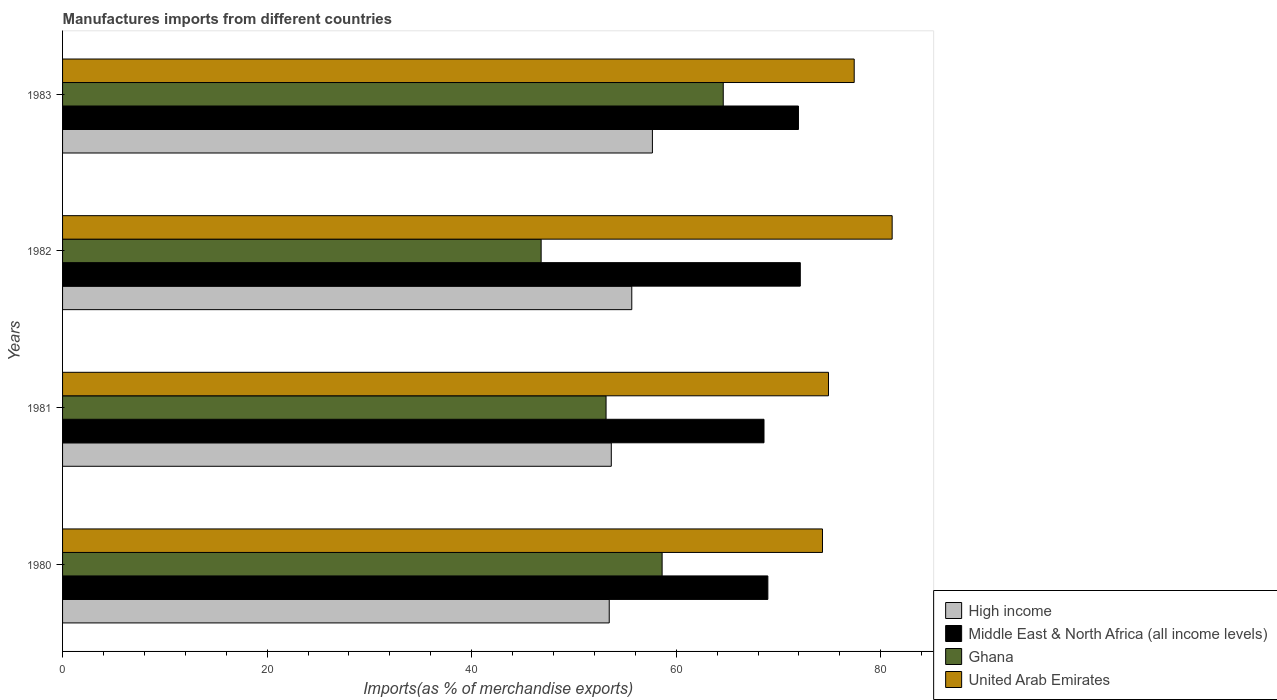How many different coloured bars are there?
Keep it short and to the point. 4. How many groups of bars are there?
Ensure brevity in your answer.  4. How many bars are there on the 1st tick from the top?
Your answer should be compact. 4. How many bars are there on the 1st tick from the bottom?
Offer a very short reply. 4. What is the label of the 1st group of bars from the top?
Keep it short and to the point. 1983. In how many cases, is the number of bars for a given year not equal to the number of legend labels?
Your response must be concise. 0. What is the percentage of imports to different countries in High income in 1982?
Ensure brevity in your answer.  55.65. Across all years, what is the maximum percentage of imports to different countries in Middle East & North Africa (all income levels)?
Your answer should be compact. 72.13. Across all years, what is the minimum percentage of imports to different countries in Middle East & North Africa (all income levels)?
Give a very brief answer. 68.58. What is the total percentage of imports to different countries in High income in the graph?
Your answer should be compact. 220.42. What is the difference between the percentage of imports to different countries in Middle East & North Africa (all income levels) in 1980 and that in 1983?
Make the answer very short. -2.99. What is the difference between the percentage of imports to different countries in Ghana in 1980 and the percentage of imports to different countries in United Arab Emirates in 1982?
Provide a short and direct response. -22.49. What is the average percentage of imports to different countries in United Arab Emirates per year?
Provide a succinct answer. 76.92. In the year 1982, what is the difference between the percentage of imports to different countries in Middle East & North Africa (all income levels) and percentage of imports to different countries in United Arab Emirates?
Keep it short and to the point. -8.98. In how many years, is the percentage of imports to different countries in Ghana greater than 72 %?
Your answer should be compact. 0. What is the ratio of the percentage of imports to different countries in Ghana in 1981 to that in 1982?
Offer a very short reply. 1.14. Is the percentage of imports to different countries in Middle East & North Africa (all income levels) in 1980 less than that in 1983?
Provide a short and direct response. Yes. What is the difference between the highest and the second highest percentage of imports to different countries in Ghana?
Provide a short and direct response. 5.98. What is the difference between the highest and the lowest percentage of imports to different countries in Ghana?
Offer a terse response. 17.8. In how many years, is the percentage of imports to different countries in United Arab Emirates greater than the average percentage of imports to different countries in United Arab Emirates taken over all years?
Provide a short and direct response. 2. Is it the case that in every year, the sum of the percentage of imports to different countries in High income and percentage of imports to different countries in Middle East & North Africa (all income levels) is greater than the sum of percentage of imports to different countries in Ghana and percentage of imports to different countries in United Arab Emirates?
Ensure brevity in your answer.  No. What does the 3rd bar from the top in 1982 represents?
Ensure brevity in your answer.  Middle East & North Africa (all income levels). Are all the bars in the graph horizontal?
Make the answer very short. Yes. Are the values on the major ticks of X-axis written in scientific E-notation?
Offer a very short reply. No. Does the graph contain any zero values?
Your answer should be compact. No. What is the title of the graph?
Ensure brevity in your answer.  Manufactures imports from different countries. Does "Samoa" appear as one of the legend labels in the graph?
Offer a terse response. No. What is the label or title of the X-axis?
Your answer should be very brief. Imports(as % of merchandise exports). What is the Imports(as % of merchandise exports) of High income in 1980?
Offer a terse response. 53.45. What is the Imports(as % of merchandise exports) in Middle East & North Africa (all income levels) in 1980?
Ensure brevity in your answer.  68.96. What is the Imports(as % of merchandise exports) of Ghana in 1980?
Give a very brief answer. 58.62. What is the Imports(as % of merchandise exports) of United Arab Emirates in 1980?
Make the answer very short. 74.3. What is the Imports(as % of merchandise exports) of High income in 1981?
Offer a terse response. 53.65. What is the Imports(as % of merchandise exports) in Middle East & North Africa (all income levels) in 1981?
Keep it short and to the point. 68.58. What is the Imports(as % of merchandise exports) of Ghana in 1981?
Offer a terse response. 53.14. What is the Imports(as % of merchandise exports) of United Arab Emirates in 1981?
Provide a short and direct response. 74.88. What is the Imports(as % of merchandise exports) in High income in 1982?
Make the answer very short. 55.65. What is the Imports(as % of merchandise exports) in Middle East & North Africa (all income levels) in 1982?
Your response must be concise. 72.13. What is the Imports(as % of merchandise exports) in Ghana in 1982?
Keep it short and to the point. 46.79. What is the Imports(as % of merchandise exports) of United Arab Emirates in 1982?
Offer a very short reply. 81.11. What is the Imports(as % of merchandise exports) of High income in 1983?
Provide a succinct answer. 57.67. What is the Imports(as % of merchandise exports) in Middle East & North Africa (all income levels) in 1983?
Provide a succinct answer. 71.95. What is the Imports(as % of merchandise exports) of Ghana in 1983?
Your answer should be very brief. 64.59. What is the Imports(as % of merchandise exports) of United Arab Emirates in 1983?
Your response must be concise. 77.4. Across all years, what is the maximum Imports(as % of merchandise exports) of High income?
Make the answer very short. 57.67. Across all years, what is the maximum Imports(as % of merchandise exports) in Middle East & North Africa (all income levels)?
Provide a succinct answer. 72.13. Across all years, what is the maximum Imports(as % of merchandise exports) in Ghana?
Ensure brevity in your answer.  64.59. Across all years, what is the maximum Imports(as % of merchandise exports) of United Arab Emirates?
Your response must be concise. 81.11. Across all years, what is the minimum Imports(as % of merchandise exports) in High income?
Your answer should be very brief. 53.45. Across all years, what is the minimum Imports(as % of merchandise exports) of Middle East & North Africa (all income levels)?
Provide a succinct answer. 68.58. Across all years, what is the minimum Imports(as % of merchandise exports) of Ghana?
Ensure brevity in your answer.  46.79. Across all years, what is the minimum Imports(as % of merchandise exports) of United Arab Emirates?
Ensure brevity in your answer.  74.3. What is the total Imports(as % of merchandise exports) in High income in the graph?
Provide a succinct answer. 220.42. What is the total Imports(as % of merchandise exports) of Middle East & North Africa (all income levels) in the graph?
Provide a short and direct response. 281.61. What is the total Imports(as % of merchandise exports) in Ghana in the graph?
Your answer should be compact. 223.14. What is the total Imports(as % of merchandise exports) in United Arab Emirates in the graph?
Make the answer very short. 307.69. What is the difference between the Imports(as % of merchandise exports) in High income in 1980 and that in 1981?
Give a very brief answer. -0.2. What is the difference between the Imports(as % of merchandise exports) of Middle East & North Africa (all income levels) in 1980 and that in 1981?
Give a very brief answer. 0.38. What is the difference between the Imports(as % of merchandise exports) of Ghana in 1980 and that in 1981?
Provide a short and direct response. 5.48. What is the difference between the Imports(as % of merchandise exports) of United Arab Emirates in 1980 and that in 1981?
Provide a succinct answer. -0.59. What is the difference between the Imports(as % of merchandise exports) in High income in 1980 and that in 1982?
Give a very brief answer. -2.2. What is the difference between the Imports(as % of merchandise exports) of Middle East & North Africa (all income levels) in 1980 and that in 1982?
Give a very brief answer. -3.17. What is the difference between the Imports(as % of merchandise exports) of Ghana in 1980 and that in 1982?
Your answer should be compact. 11.83. What is the difference between the Imports(as % of merchandise exports) in United Arab Emirates in 1980 and that in 1982?
Offer a very short reply. -6.81. What is the difference between the Imports(as % of merchandise exports) of High income in 1980 and that in 1983?
Ensure brevity in your answer.  -4.22. What is the difference between the Imports(as % of merchandise exports) in Middle East & North Africa (all income levels) in 1980 and that in 1983?
Offer a terse response. -2.99. What is the difference between the Imports(as % of merchandise exports) of Ghana in 1980 and that in 1983?
Your answer should be compact. -5.98. What is the difference between the Imports(as % of merchandise exports) in United Arab Emirates in 1980 and that in 1983?
Ensure brevity in your answer.  -3.1. What is the difference between the Imports(as % of merchandise exports) in High income in 1981 and that in 1982?
Your response must be concise. -2. What is the difference between the Imports(as % of merchandise exports) in Middle East & North Africa (all income levels) in 1981 and that in 1982?
Offer a very short reply. -3.55. What is the difference between the Imports(as % of merchandise exports) in Ghana in 1981 and that in 1982?
Your answer should be very brief. 6.35. What is the difference between the Imports(as % of merchandise exports) in United Arab Emirates in 1981 and that in 1982?
Provide a short and direct response. -6.23. What is the difference between the Imports(as % of merchandise exports) in High income in 1981 and that in 1983?
Ensure brevity in your answer.  -4.02. What is the difference between the Imports(as % of merchandise exports) of Middle East & North Africa (all income levels) in 1981 and that in 1983?
Give a very brief answer. -3.37. What is the difference between the Imports(as % of merchandise exports) of Ghana in 1981 and that in 1983?
Your answer should be very brief. -11.46. What is the difference between the Imports(as % of merchandise exports) in United Arab Emirates in 1981 and that in 1983?
Your answer should be very brief. -2.51. What is the difference between the Imports(as % of merchandise exports) of High income in 1982 and that in 1983?
Make the answer very short. -2.02. What is the difference between the Imports(as % of merchandise exports) in Middle East & North Africa (all income levels) in 1982 and that in 1983?
Offer a terse response. 0.18. What is the difference between the Imports(as % of merchandise exports) in Ghana in 1982 and that in 1983?
Your response must be concise. -17.8. What is the difference between the Imports(as % of merchandise exports) in United Arab Emirates in 1982 and that in 1983?
Offer a terse response. 3.71. What is the difference between the Imports(as % of merchandise exports) in High income in 1980 and the Imports(as % of merchandise exports) in Middle East & North Africa (all income levels) in 1981?
Your answer should be compact. -15.13. What is the difference between the Imports(as % of merchandise exports) of High income in 1980 and the Imports(as % of merchandise exports) of Ghana in 1981?
Ensure brevity in your answer.  0.31. What is the difference between the Imports(as % of merchandise exports) of High income in 1980 and the Imports(as % of merchandise exports) of United Arab Emirates in 1981?
Your answer should be compact. -21.44. What is the difference between the Imports(as % of merchandise exports) in Middle East & North Africa (all income levels) in 1980 and the Imports(as % of merchandise exports) in Ghana in 1981?
Provide a succinct answer. 15.82. What is the difference between the Imports(as % of merchandise exports) of Middle East & North Africa (all income levels) in 1980 and the Imports(as % of merchandise exports) of United Arab Emirates in 1981?
Offer a terse response. -5.93. What is the difference between the Imports(as % of merchandise exports) in Ghana in 1980 and the Imports(as % of merchandise exports) in United Arab Emirates in 1981?
Ensure brevity in your answer.  -16.27. What is the difference between the Imports(as % of merchandise exports) in High income in 1980 and the Imports(as % of merchandise exports) in Middle East & North Africa (all income levels) in 1982?
Give a very brief answer. -18.68. What is the difference between the Imports(as % of merchandise exports) of High income in 1980 and the Imports(as % of merchandise exports) of Ghana in 1982?
Keep it short and to the point. 6.66. What is the difference between the Imports(as % of merchandise exports) in High income in 1980 and the Imports(as % of merchandise exports) in United Arab Emirates in 1982?
Provide a succinct answer. -27.66. What is the difference between the Imports(as % of merchandise exports) in Middle East & North Africa (all income levels) in 1980 and the Imports(as % of merchandise exports) in Ghana in 1982?
Give a very brief answer. 22.17. What is the difference between the Imports(as % of merchandise exports) of Middle East & North Africa (all income levels) in 1980 and the Imports(as % of merchandise exports) of United Arab Emirates in 1982?
Your answer should be compact. -12.15. What is the difference between the Imports(as % of merchandise exports) in Ghana in 1980 and the Imports(as % of merchandise exports) in United Arab Emirates in 1982?
Make the answer very short. -22.49. What is the difference between the Imports(as % of merchandise exports) in High income in 1980 and the Imports(as % of merchandise exports) in Middle East & North Africa (all income levels) in 1983?
Your response must be concise. -18.5. What is the difference between the Imports(as % of merchandise exports) of High income in 1980 and the Imports(as % of merchandise exports) of Ghana in 1983?
Make the answer very short. -11.15. What is the difference between the Imports(as % of merchandise exports) in High income in 1980 and the Imports(as % of merchandise exports) in United Arab Emirates in 1983?
Keep it short and to the point. -23.95. What is the difference between the Imports(as % of merchandise exports) in Middle East & North Africa (all income levels) in 1980 and the Imports(as % of merchandise exports) in Ghana in 1983?
Your answer should be compact. 4.36. What is the difference between the Imports(as % of merchandise exports) of Middle East & North Africa (all income levels) in 1980 and the Imports(as % of merchandise exports) of United Arab Emirates in 1983?
Provide a succinct answer. -8.44. What is the difference between the Imports(as % of merchandise exports) in Ghana in 1980 and the Imports(as % of merchandise exports) in United Arab Emirates in 1983?
Offer a very short reply. -18.78. What is the difference between the Imports(as % of merchandise exports) in High income in 1981 and the Imports(as % of merchandise exports) in Middle East & North Africa (all income levels) in 1982?
Provide a short and direct response. -18.48. What is the difference between the Imports(as % of merchandise exports) of High income in 1981 and the Imports(as % of merchandise exports) of Ghana in 1982?
Provide a short and direct response. 6.86. What is the difference between the Imports(as % of merchandise exports) of High income in 1981 and the Imports(as % of merchandise exports) of United Arab Emirates in 1982?
Provide a short and direct response. -27.46. What is the difference between the Imports(as % of merchandise exports) in Middle East & North Africa (all income levels) in 1981 and the Imports(as % of merchandise exports) in Ghana in 1982?
Provide a short and direct response. 21.79. What is the difference between the Imports(as % of merchandise exports) of Middle East & North Africa (all income levels) in 1981 and the Imports(as % of merchandise exports) of United Arab Emirates in 1982?
Provide a succinct answer. -12.53. What is the difference between the Imports(as % of merchandise exports) of Ghana in 1981 and the Imports(as % of merchandise exports) of United Arab Emirates in 1982?
Your answer should be compact. -27.97. What is the difference between the Imports(as % of merchandise exports) of High income in 1981 and the Imports(as % of merchandise exports) of Middle East & North Africa (all income levels) in 1983?
Keep it short and to the point. -18.3. What is the difference between the Imports(as % of merchandise exports) in High income in 1981 and the Imports(as % of merchandise exports) in Ghana in 1983?
Your answer should be compact. -10.95. What is the difference between the Imports(as % of merchandise exports) in High income in 1981 and the Imports(as % of merchandise exports) in United Arab Emirates in 1983?
Offer a terse response. -23.75. What is the difference between the Imports(as % of merchandise exports) in Middle East & North Africa (all income levels) in 1981 and the Imports(as % of merchandise exports) in Ghana in 1983?
Your response must be concise. 3.98. What is the difference between the Imports(as % of merchandise exports) in Middle East & North Africa (all income levels) in 1981 and the Imports(as % of merchandise exports) in United Arab Emirates in 1983?
Give a very brief answer. -8.82. What is the difference between the Imports(as % of merchandise exports) of Ghana in 1981 and the Imports(as % of merchandise exports) of United Arab Emirates in 1983?
Your answer should be compact. -24.26. What is the difference between the Imports(as % of merchandise exports) of High income in 1982 and the Imports(as % of merchandise exports) of Middle East & North Africa (all income levels) in 1983?
Provide a succinct answer. -16.3. What is the difference between the Imports(as % of merchandise exports) in High income in 1982 and the Imports(as % of merchandise exports) in Ghana in 1983?
Provide a succinct answer. -8.94. What is the difference between the Imports(as % of merchandise exports) of High income in 1982 and the Imports(as % of merchandise exports) of United Arab Emirates in 1983?
Offer a very short reply. -21.75. What is the difference between the Imports(as % of merchandise exports) of Middle East & North Africa (all income levels) in 1982 and the Imports(as % of merchandise exports) of Ghana in 1983?
Make the answer very short. 7.53. What is the difference between the Imports(as % of merchandise exports) in Middle East & North Africa (all income levels) in 1982 and the Imports(as % of merchandise exports) in United Arab Emirates in 1983?
Your answer should be compact. -5.27. What is the difference between the Imports(as % of merchandise exports) of Ghana in 1982 and the Imports(as % of merchandise exports) of United Arab Emirates in 1983?
Keep it short and to the point. -30.61. What is the average Imports(as % of merchandise exports) of High income per year?
Provide a succinct answer. 55.1. What is the average Imports(as % of merchandise exports) in Middle East & North Africa (all income levels) per year?
Your answer should be very brief. 70.4. What is the average Imports(as % of merchandise exports) in Ghana per year?
Provide a succinct answer. 55.79. What is the average Imports(as % of merchandise exports) in United Arab Emirates per year?
Your answer should be very brief. 76.92. In the year 1980, what is the difference between the Imports(as % of merchandise exports) of High income and Imports(as % of merchandise exports) of Middle East & North Africa (all income levels)?
Keep it short and to the point. -15.51. In the year 1980, what is the difference between the Imports(as % of merchandise exports) in High income and Imports(as % of merchandise exports) in Ghana?
Offer a terse response. -5.17. In the year 1980, what is the difference between the Imports(as % of merchandise exports) of High income and Imports(as % of merchandise exports) of United Arab Emirates?
Ensure brevity in your answer.  -20.85. In the year 1980, what is the difference between the Imports(as % of merchandise exports) in Middle East & North Africa (all income levels) and Imports(as % of merchandise exports) in Ghana?
Your answer should be very brief. 10.34. In the year 1980, what is the difference between the Imports(as % of merchandise exports) in Middle East & North Africa (all income levels) and Imports(as % of merchandise exports) in United Arab Emirates?
Offer a very short reply. -5.34. In the year 1980, what is the difference between the Imports(as % of merchandise exports) of Ghana and Imports(as % of merchandise exports) of United Arab Emirates?
Your answer should be very brief. -15.68. In the year 1981, what is the difference between the Imports(as % of merchandise exports) in High income and Imports(as % of merchandise exports) in Middle East & North Africa (all income levels)?
Give a very brief answer. -14.93. In the year 1981, what is the difference between the Imports(as % of merchandise exports) of High income and Imports(as % of merchandise exports) of Ghana?
Offer a terse response. 0.51. In the year 1981, what is the difference between the Imports(as % of merchandise exports) of High income and Imports(as % of merchandise exports) of United Arab Emirates?
Ensure brevity in your answer.  -21.23. In the year 1981, what is the difference between the Imports(as % of merchandise exports) of Middle East & North Africa (all income levels) and Imports(as % of merchandise exports) of Ghana?
Make the answer very short. 15.44. In the year 1981, what is the difference between the Imports(as % of merchandise exports) in Middle East & North Africa (all income levels) and Imports(as % of merchandise exports) in United Arab Emirates?
Ensure brevity in your answer.  -6.3. In the year 1981, what is the difference between the Imports(as % of merchandise exports) of Ghana and Imports(as % of merchandise exports) of United Arab Emirates?
Keep it short and to the point. -21.75. In the year 1982, what is the difference between the Imports(as % of merchandise exports) in High income and Imports(as % of merchandise exports) in Middle East & North Africa (all income levels)?
Give a very brief answer. -16.48. In the year 1982, what is the difference between the Imports(as % of merchandise exports) in High income and Imports(as % of merchandise exports) in Ghana?
Provide a succinct answer. 8.86. In the year 1982, what is the difference between the Imports(as % of merchandise exports) in High income and Imports(as % of merchandise exports) in United Arab Emirates?
Offer a very short reply. -25.46. In the year 1982, what is the difference between the Imports(as % of merchandise exports) in Middle East & North Africa (all income levels) and Imports(as % of merchandise exports) in Ghana?
Offer a very short reply. 25.34. In the year 1982, what is the difference between the Imports(as % of merchandise exports) of Middle East & North Africa (all income levels) and Imports(as % of merchandise exports) of United Arab Emirates?
Offer a terse response. -8.98. In the year 1982, what is the difference between the Imports(as % of merchandise exports) of Ghana and Imports(as % of merchandise exports) of United Arab Emirates?
Provide a succinct answer. -34.32. In the year 1983, what is the difference between the Imports(as % of merchandise exports) in High income and Imports(as % of merchandise exports) in Middle East & North Africa (all income levels)?
Give a very brief answer. -14.28. In the year 1983, what is the difference between the Imports(as % of merchandise exports) of High income and Imports(as % of merchandise exports) of Ghana?
Offer a very short reply. -6.93. In the year 1983, what is the difference between the Imports(as % of merchandise exports) in High income and Imports(as % of merchandise exports) in United Arab Emirates?
Make the answer very short. -19.73. In the year 1983, what is the difference between the Imports(as % of merchandise exports) in Middle East & North Africa (all income levels) and Imports(as % of merchandise exports) in Ghana?
Provide a short and direct response. 7.35. In the year 1983, what is the difference between the Imports(as % of merchandise exports) in Middle East & North Africa (all income levels) and Imports(as % of merchandise exports) in United Arab Emirates?
Provide a succinct answer. -5.45. In the year 1983, what is the difference between the Imports(as % of merchandise exports) in Ghana and Imports(as % of merchandise exports) in United Arab Emirates?
Provide a short and direct response. -12.8. What is the ratio of the Imports(as % of merchandise exports) of Ghana in 1980 to that in 1981?
Make the answer very short. 1.1. What is the ratio of the Imports(as % of merchandise exports) of High income in 1980 to that in 1982?
Give a very brief answer. 0.96. What is the ratio of the Imports(as % of merchandise exports) of Middle East & North Africa (all income levels) in 1980 to that in 1982?
Your answer should be very brief. 0.96. What is the ratio of the Imports(as % of merchandise exports) of Ghana in 1980 to that in 1982?
Give a very brief answer. 1.25. What is the ratio of the Imports(as % of merchandise exports) in United Arab Emirates in 1980 to that in 1982?
Your response must be concise. 0.92. What is the ratio of the Imports(as % of merchandise exports) in High income in 1980 to that in 1983?
Offer a very short reply. 0.93. What is the ratio of the Imports(as % of merchandise exports) in Middle East & North Africa (all income levels) in 1980 to that in 1983?
Make the answer very short. 0.96. What is the ratio of the Imports(as % of merchandise exports) in Ghana in 1980 to that in 1983?
Your answer should be compact. 0.91. What is the ratio of the Imports(as % of merchandise exports) in United Arab Emirates in 1980 to that in 1983?
Provide a succinct answer. 0.96. What is the ratio of the Imports(as % of merchandise exports) in Middle East & North Africa (all income levels) in 1981 to that in 1982?
Offer a very short reply. 0.95. What is the ratio of the Imports(as % of merchandise exports) in Ghana in 1981 to that in 1982?
Your response must be concise. 1.14. What is the ratio of the Imports(as % of merchandise exports) of United Arab Emirates in 1981 to that in 1982?
Ensure brevity in your answer.  0.92. What is the ratio of the Imports(as % of merchandise exports) of High income in 1981 to that in 1983?
Your response must be concise. 0.93. What is the ratio of the Imports(as % of merchandise exports) in Middle East & North Africa (all income levels) in 1981 to that in 1983?
Your answer should be compact. 0.95. What is the ratio of the Imports(as % of merchandise exports) in Ghana in 1981 to that in 1983?
Give a very brief answer. 0.82. What is the ratio of the Imports(as % of merchandise exports) in United Arab Emirates in 1981 to that in 1983?
Provide a succinct answer. 0.97. What is the ratio of the Imports(as % of merchandise exports) of Middle East & North Africa (all income levels) in 1982 to that in 1983?
Your answer should be compact. 1. What is the ratio of the Imports(as % of merchandise exports) in Ghana in 1982 to that in 1983?
Make the answer very short. 0.72. What is the ratio of the Imports(as % of merchandise exports) in United Arab Emirates in 1982 to that in 1983?
Provide a succinct answer. 1.05. What is the difference between the highest and the second highest Imports(as % of merchandise exports) of High income?
Give a very brief answer. 2.02. What is the difference between the highest and the second highest Imports(as % of merchandise exports) of Middle East & North Africa (all income levels)?
Provide a short and direct response. 0.18. What is the difference between the highest and the second highest Imports(as % of merchandise exports) of Ghana?
Offer a terse response. 5.98. What is the difference between the highest and the second highest Imports(as % of merchandise exports) in United Arab Emirates?
Ensure brevity in your answer.  3.71. What is the difference between the highest and the lowest Imports(as % of merchandise exports) of High income?
Offer a very short reply. 4.22. What is the difference between the highest and the lowest Imports(as % of merchandise exports) in Middle East & North Africa (all income levels)?
Make the answer very short. 3.55. What is the difference between the highest and the lowest Imports(as % of merchandise exports) in Ghana?
Your answer should be very brief. 17.8. What is the difference between the highest and the lowest Imports(as % of merchandise exports) of United Arab Emirates?
Offer a terse response. 6.81. 